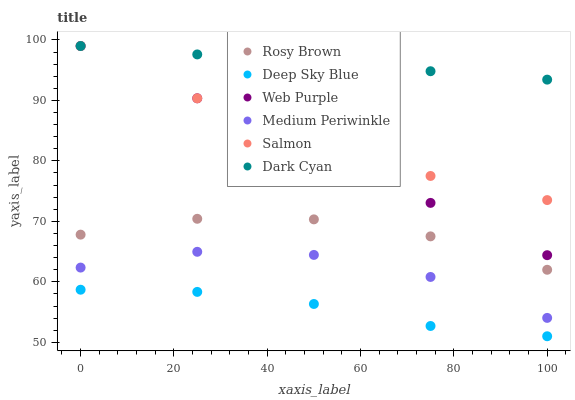Does Deep Sky Blue have the minimum area under the curve?
Answer yes or no. Yes. Does Dark Cyan have the maximum area under the curve?
Answer yes or no. Yes. Does Rosy Brown have the minimum area under the curve?
Answer yes or no. No. Does Rosy Brown have the maximum area under the curve?
Answer yes or no. No. Is Web Purple the smoothest?
Answer yes or no. Yes. Is Medium Periwinkle the roughest?
Answer yes or no. Yes. Is Rosy Brown the smoothest?
Answer yes or no. No. Is Rosy Brown the roughest?
Answer yes or no. No. Does Deep Sky Blue have the lowest value?
Answer yes or no. Yes. Does Rosy Brown have the lowest value?
Answer yes or no. No. Does Dark Cyan have the highest value?
Answer yes or no. Yes. Does Rosy Brown have the highest value?
Answer yes or no. No. Is Rosy Brown less than Web Purple?
Answer yes or no. Yes. Is Web Purple greater than Medium Periwinkle?
Answer yes or no. Yes. Does Dark Cyan intersect Web Purple?
Answer yes or no. Yes. Is Dark Cyan less than Web Purple?
Answer yes or no. No. Is Dark Cyan greater than Web Purple?
Answer yes or no. No. Does Rosy Brown intersect Web Purple?
Answer yes or no. No. 